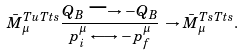<formula> <loc_0><loc_0><loc_500><loc_500>\bar { M } ^ { T u T t s } _ { \mu } \frac { Q _ { B } \longrightarrow - Q _ { B } } { p ^ { \mu } _ { i } \longleftrightarrow - p ^ { \mu } _ { f } } \, \rightarrow \bar { M } ^ { T s T t s } _ { \mu } .</formula> 